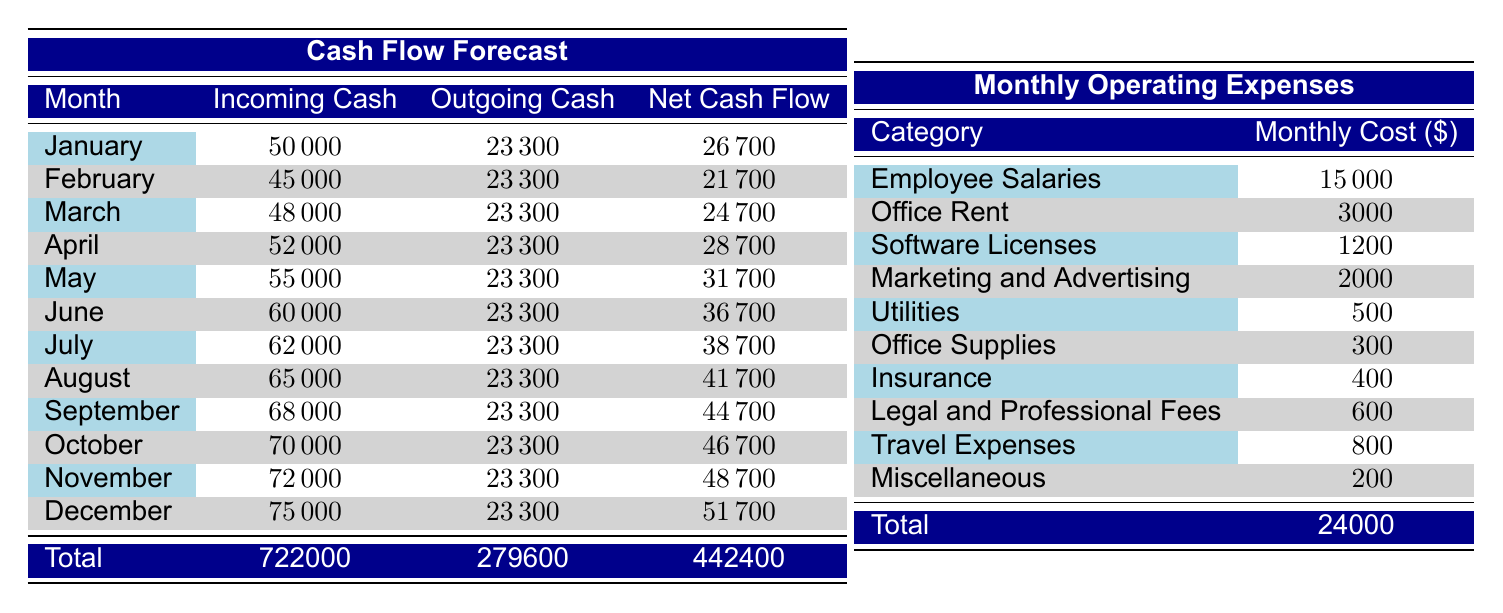What is the total monthly operating expense for the startup? The total monthly operating expense is found by summing all individual monthly costs listed in the operating expenses section. The individual costs are: 15000 + 3000 + 1200 + 2000 + 500 + 300 + 400 + 600 + 800 + 200. Summing these gives 24000.
Answer: 24000 Which month has the highest incoming cash? To find the month with the highest incoming cash, we need to look at the incoming cash values for each month and identify the maximum. The maximum incoming cash is 75000 in December.
Answer: December Is the net cash flow for January greater than the net cash flow for February? We compare the net cash flows for January (26700) and February (21700). Since 26700 is greater than 21700, the statement is true.
Answer: Yes What is the average outgoing cash flow for the months from January to March? The outgoing cash values for these three months are 23300 for each month. To find the average, we add these up (23300 + 23300 + 23300 = 69900) and divide by the number of months (3). 69900 / 3 = 23300.
Answer: 23300 How much net cash flow does the startup generate from May to July combined? We find the net cash flows for May (31700), June (36700), and July (38700) and sum them. This gives 31700 + 36700 + 38700 = 107100.
Answer: 107100 Does the total incoming cash for the year exceed the total outgoing cash? The total incoming cash for the year sums to 722000, and the total outgoing cash sums to 279600. Since 722000 is greater than 279600, the answer is yes.
Answer: Yes Which category accounts for the highest monthly expense? We look at the monthly costs by category and find that "Employee Salaries" at 15000 is the highest expense.
Answer: Employee Salaries What is the net cash flow for the month with the least incoming cash? We identify the month with the least incoming cash, which is February at 45000. The outgoing cash remains 23300, so the net cash flow is 45000 - 23300 = 21700.
Answer: 21700 How much more does the startup earn in net cash flow in December than in January? We compare the net cash flows: December has 51700 and January has 26700. The difference is 51700 - 26700 = 25000.
Answer: 25000 